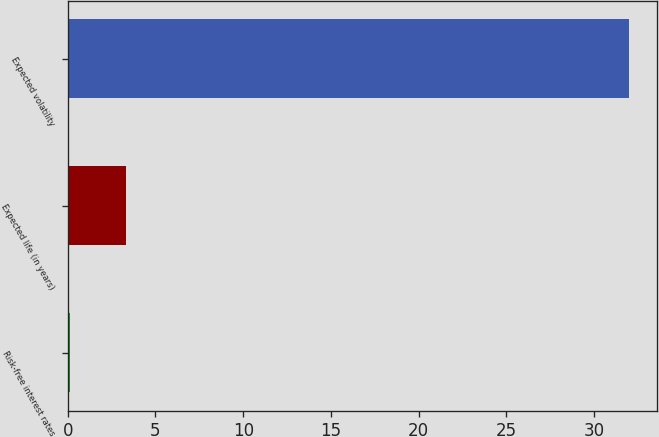Convert chart to OTSL. <chart><loc_0><loc_0><loc_500><loc_500><bar_chart><fcel>Risk-free interest rates<fcel>Expected life (in years)<fcel>Expected volatility<nl><fcel>0.11<fcel>3.3<fcel>32<nl></chart> 